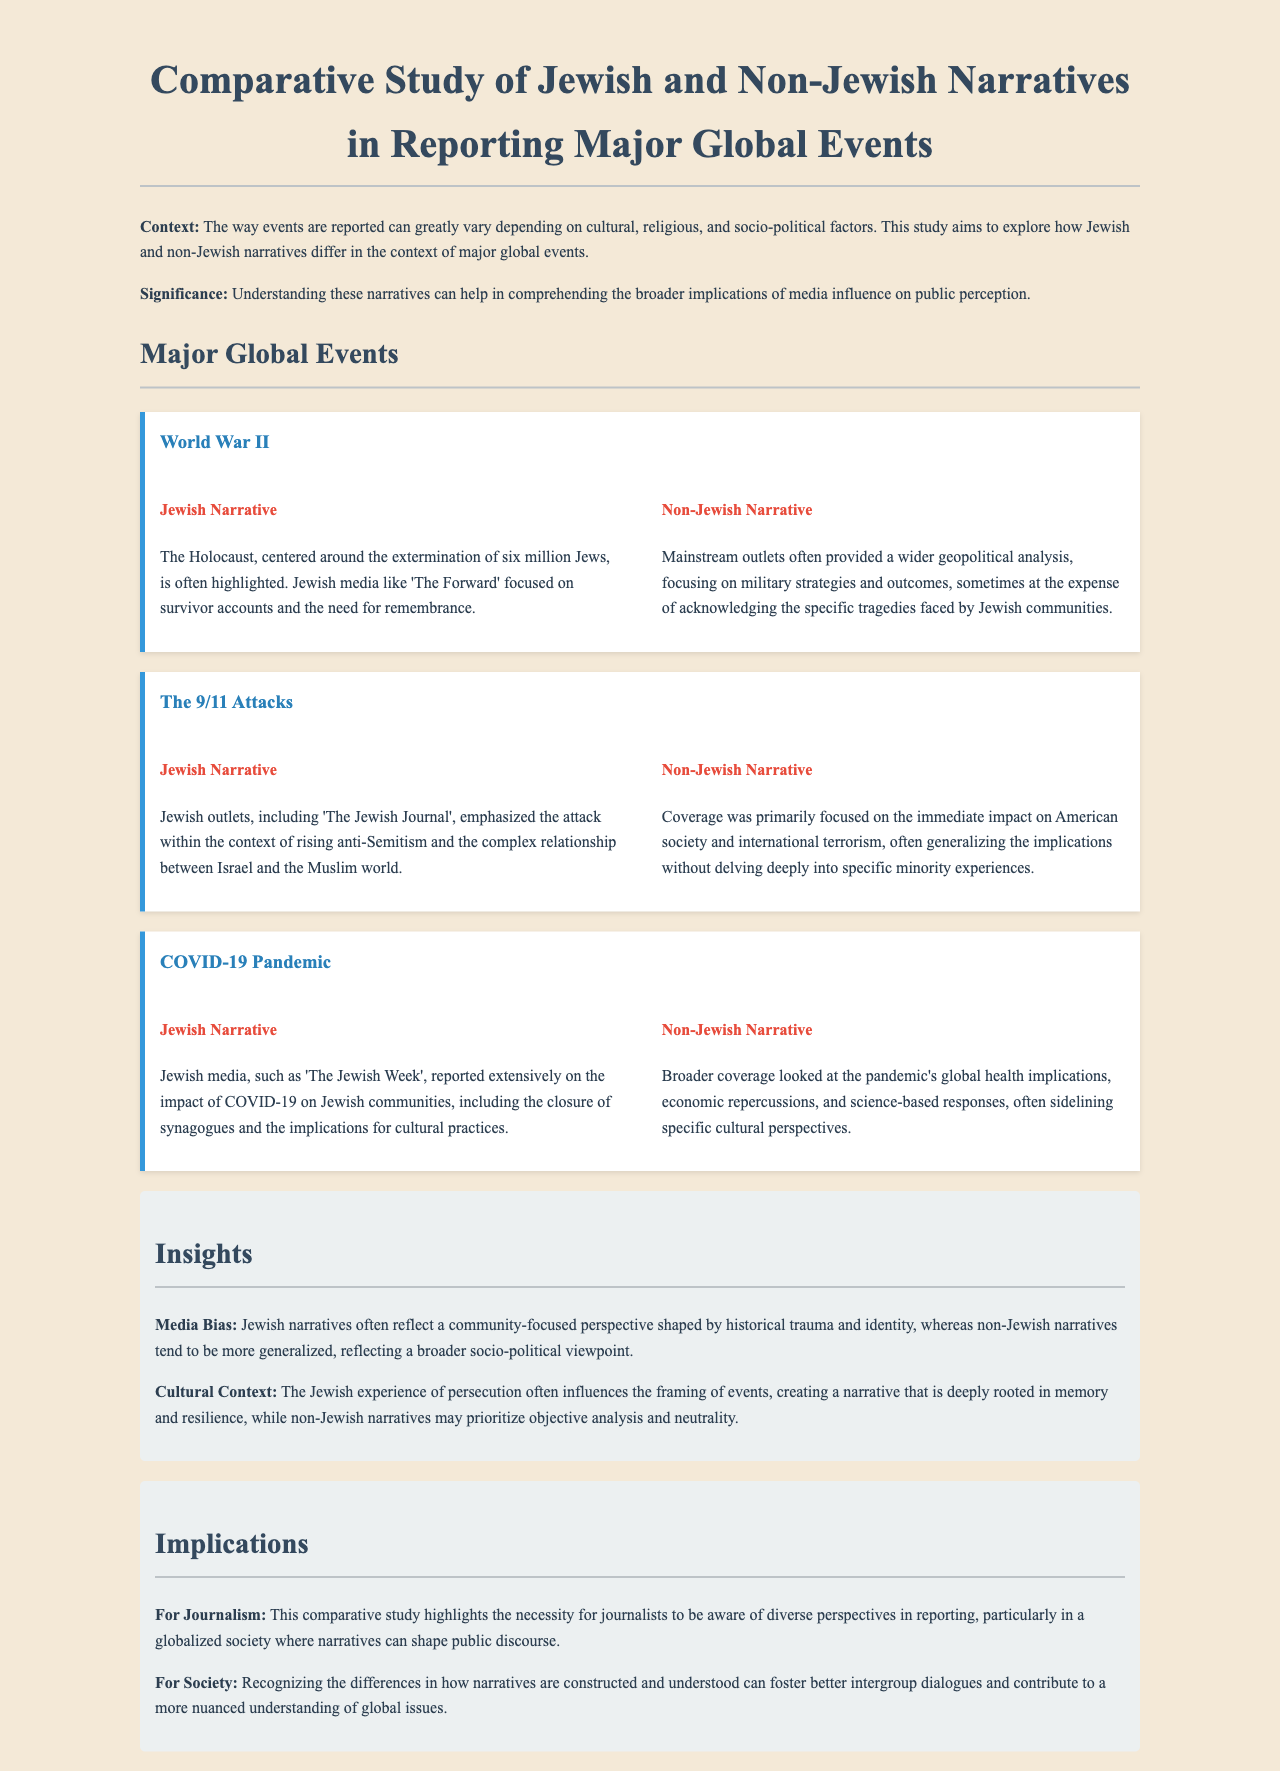What major global event is highlighted in the Jewish narrative regarding the Holocaust? The Jewish narrative specifically highlights the extermination of six million Jews during World War II, focusing on survivor accounts and the need for remembrance.
Answer: The Holocaust Which Jewish media outlet reported on the 9/11 attacks? The document mentions 'The Jewish Journal' in the context of reporting on the 9/11 attacks and their relation to anti-Semitism.
Answer: The Jewish Journal What is a key insight regarding media bias presented in the report? The report indicates that Jewish narratives often reflect a community-focused perspective, while non-Jewish narratives tend to be more generalized.
Answer: Community-focused perspective How did the non-Jewish narrative frame the coverage of COVID-19? The non-Jewish narrative looked at the pandemic's global health implications, economic repercussions, and science-based responses, often sidelining specific cultural perspectives.
Answer: Global health implications What event's reporting emphasized the impact on Jewish communities due to synagogue closures? The Jewish narrative regarding COVID-19 specifically emphasizes the impact on Jewish communities, including the closure of synagogues and implications for cultural practices.
Answer: COVID-19 Pandemic Which global event is associated with rising anti-Semitism in the Jewish narrative? The 9/11 attacks are discussed in relation to rising anti-Semitism within the Jewish narrative, reflecting on the complex relationship between Israel and the Muslim world.
Answer: The 9/11 Attacks 